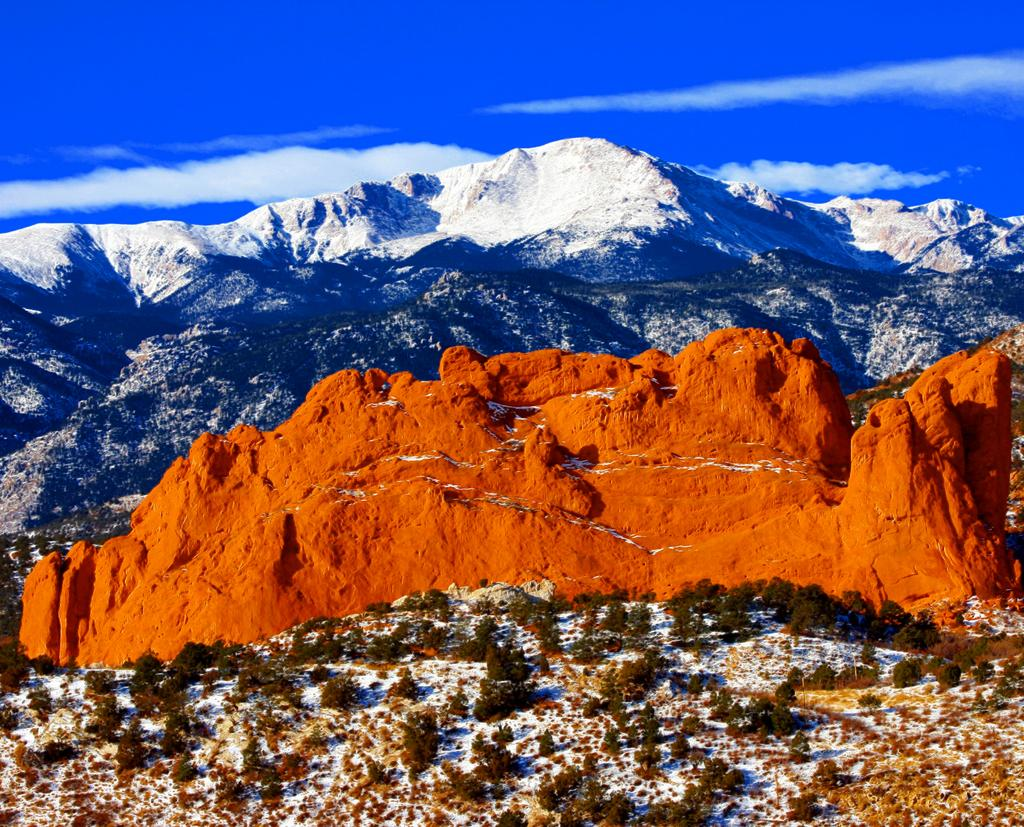What can be found at the bottom of the image? There are plants, grass, and snow at the bottom of the image. What is the terrain like at the bottom of the image? The terrain at the bottom of the image is covered in grass and snow. What is visible in the background of the image? There is a mountain and clouds visible in the sky in the background. What is the condition of the mountain in the background? The mountain in the background is covered in snow. What type of dinner is being served on the mountain in the image? There is no dinner being served in the image; it features a snow-covered mountain in the background. What error can be found in the image? There is no error present in the image; it accurately depicts a snowy landscape with a mountain in the background. 